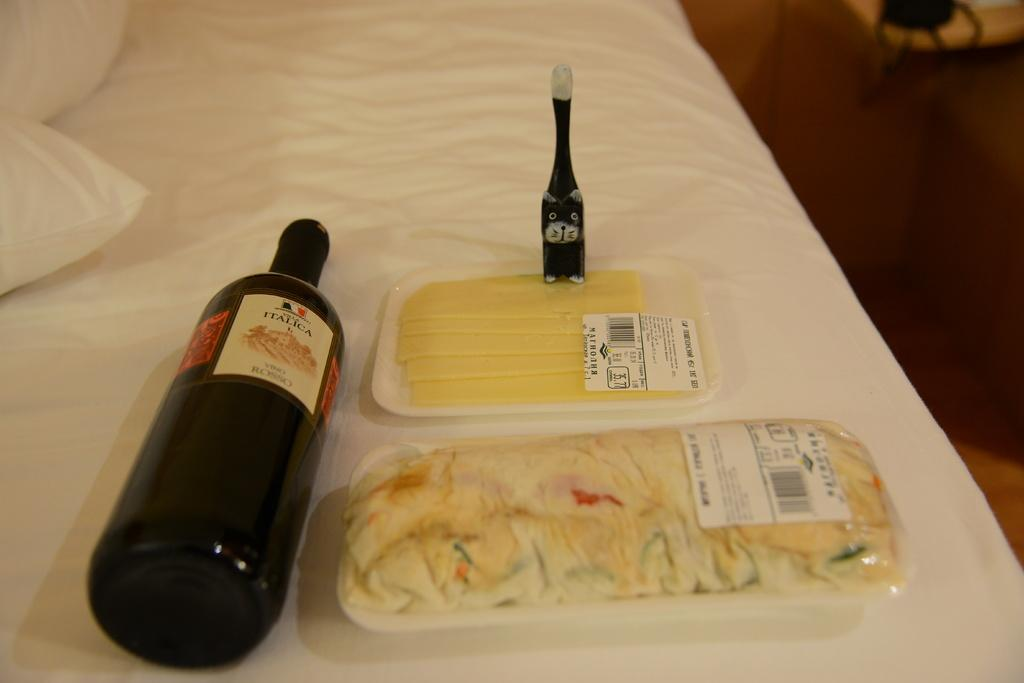<image>
Render a clear and concise summary of the photo. A black bottle of Italica laid down on its side with food next to it. 